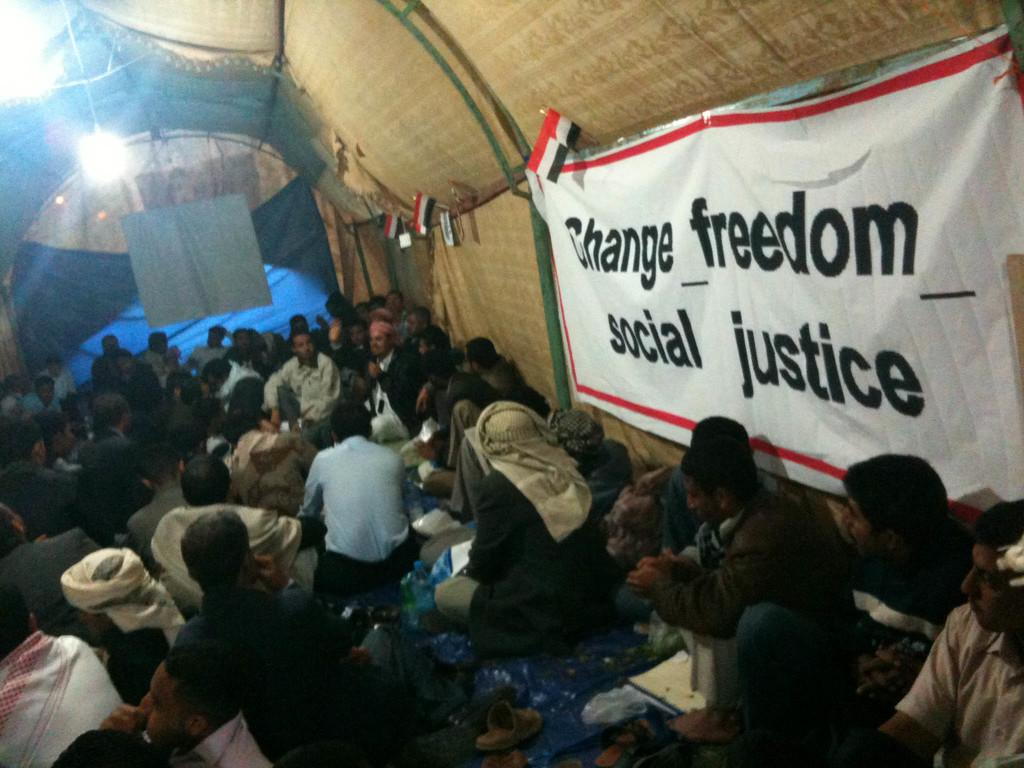What are the people in the image doing? The people in the image are sitting in a tent. What can be seen hanging in the image? There is a banner in the image. Where are the flags located in the image? The flags are on the right side of the image. What is covering the back of the tent? There is a cloth at the back of the tent. What is providing illumination in the image? Lights are present in the image. What type of basketball is being played in the image? There is no basketball or any indication of a basketball game in the image. 